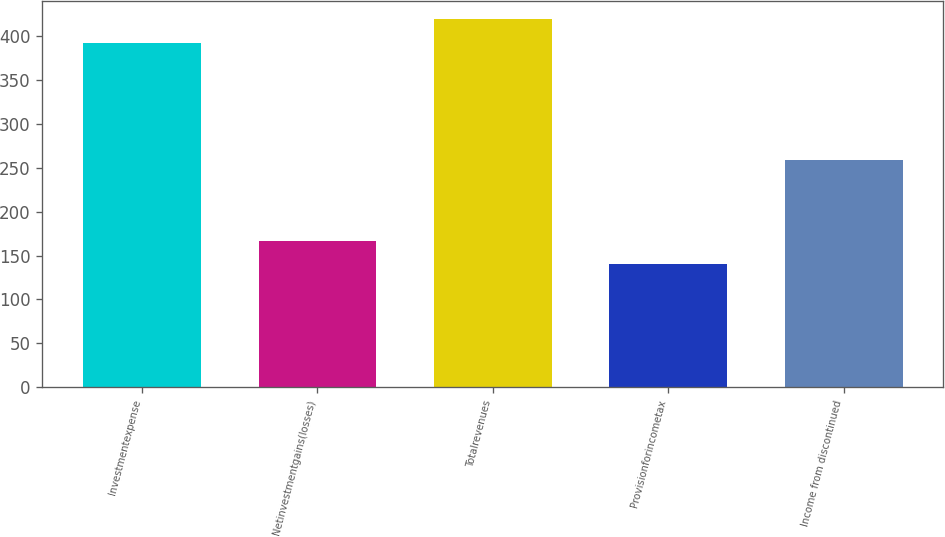<chart> <loc_0><loc_0><loc_500><loc_500><bar_chart><fcel>Investmentexpense<fcel>Netinvestmentgains(losses)<fcel>Totalrevenues<fcel>Provisionforincometax<fcel>Income from discontinued<nl><fcel>392<fcel>167.2<fcel>419.2<fcel>140<fcel>259<nl></chart> 